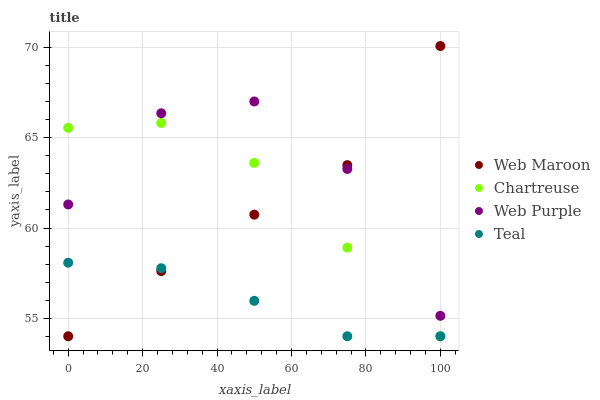Does Teal have the minimum area under the curve?
Answer yes or no. Yes. Does Web Purple have the maximum area under the curve?
Answer yes or no. Yes. Does Web Maroon have the minimum area under the curve?
Answer yes or no. No. Does Web Maroon have the maximum area under the curve?
Answer yes or no. No. Is Teal the smoothest?
Answer yes or no. Yes. Is Web Purple the roughest?
Answer yes or no. Yes. Is Web Maroon the smoothest?
Answer yes or no. No. Is Web Maroon the roughest?
Answer yes or no. No. Does Chartreuse have the lowest value?
Answer yes or no. Yes. Does Web Purple have the lowest value?
Answer yes or no. No. Does Web Maroon have the highest value?
Answer yes or no. Yes. Does Web Purple have the highest value?
Answer yes or no. No. Is Teal less than Web Purple?
Answer yes or no. Yes. Is Web Purple greater than Teal?
Answer yes or no. Yes. Does Chartreuse intersect Web Purple?
Answer yes or no. Yes. Is Chartreuse less than Web Purple?
Answer yes or no. No. Is Chartreuse greater than Web Purple?
Answer yes or no. No. Does Teal intersect Web Purple?
Answer yes or no. No. 